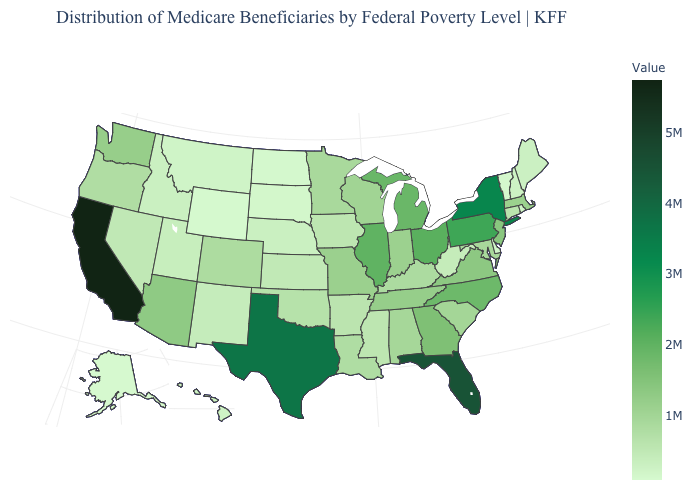Is the legend a continuous bar?
Give a very brief answer. Yes. Among the states that border Nevada , which have the lowest value?
Keep it brief. Idaho. Among the states that border South Carolina , does Georgia have the highest value?
Be succinct. No. Is the legend a continuous bar?
Be succinct. Yes. Does Massachusetts have the highest value in the USA?
Keep it brief. No. Is the legend a continuous bar?
Write a very short answer. Yes. 